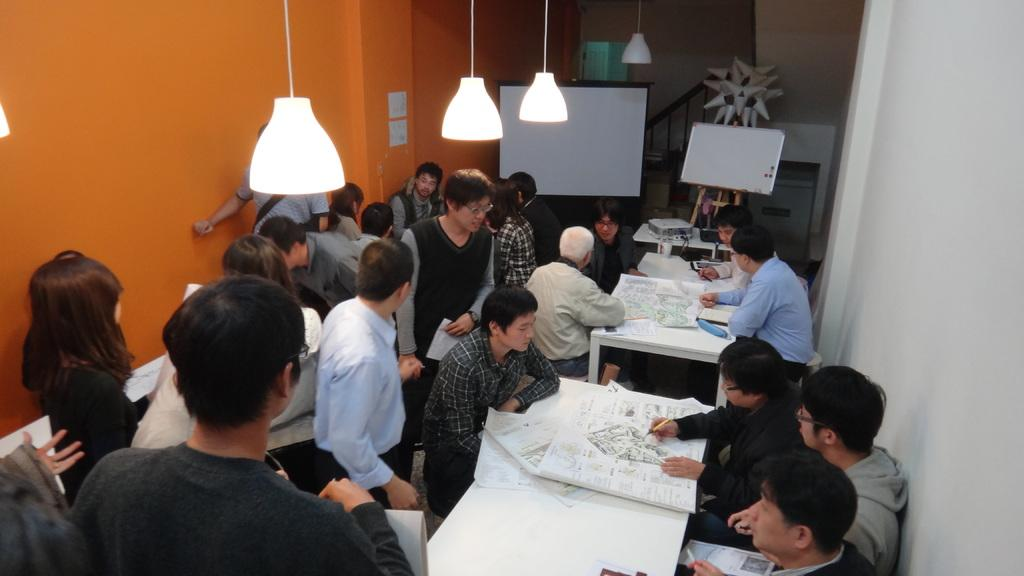What are the people in the image doing? The people standing in the image are holding papers in their hands. Are there any people sitting in the image? Yes, there are people sitting on the right side of the image. What are the people sitting on the right side doing? The people sitting on the right side are explaining from a chart. What type of art is being created by the people in the image? There is no indication in the image that the people are creating any art. 